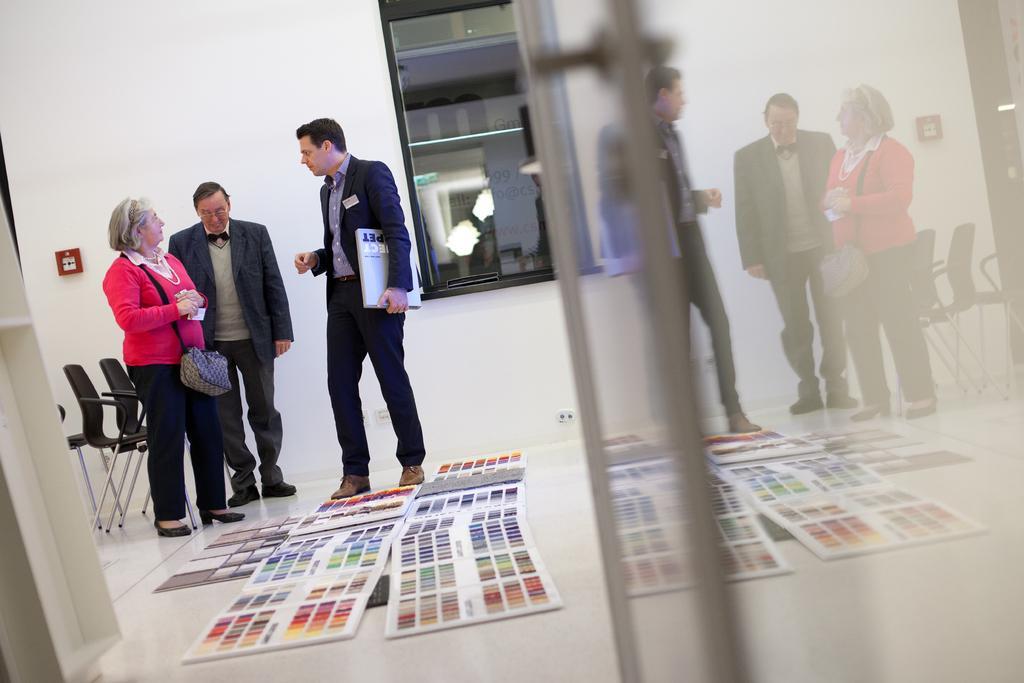Please provide a concise description of this image. In the image we can see there are people standing and a man is holding book in his hand. There are chairs at the back and there are colour palettes kept on the floor. 